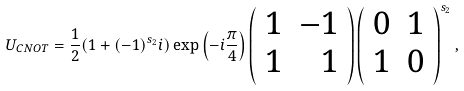<formula> <loc_0><loc_0><loc_500><loc_500>U _ { C N O T } = \frac { 1 } { 2 } ( 1 + ( - 1 ) ^ { s _ { 2 } } i ) \exp \left ( { - i \frac { \pi } { 4 } } \right ) \left ( \begin{array} [ c ] { c r } 1 & - 1 \\ 1 & 1 \end{array} \right ) \left ( \begin{array} [ c ] { c c } 0 & 1 \\ 1 & 0 \end{array} \right ) ^ { s _ { 2 } } ,</formula> 